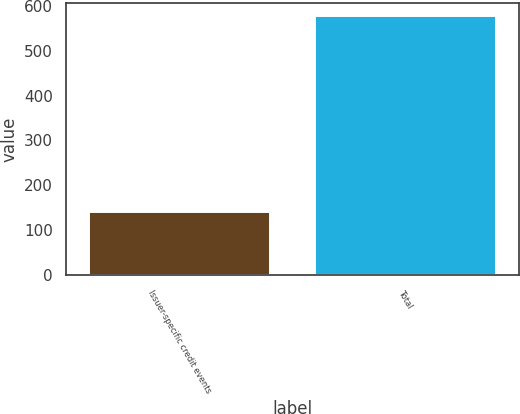Convert chart. <chart><loc_0><loc_0><loc_500><loc_500><bar_chart><fcel>Issuer-specific credit events<fcel>Total<nl><fcel>141<fcel>577<nl></chart> 